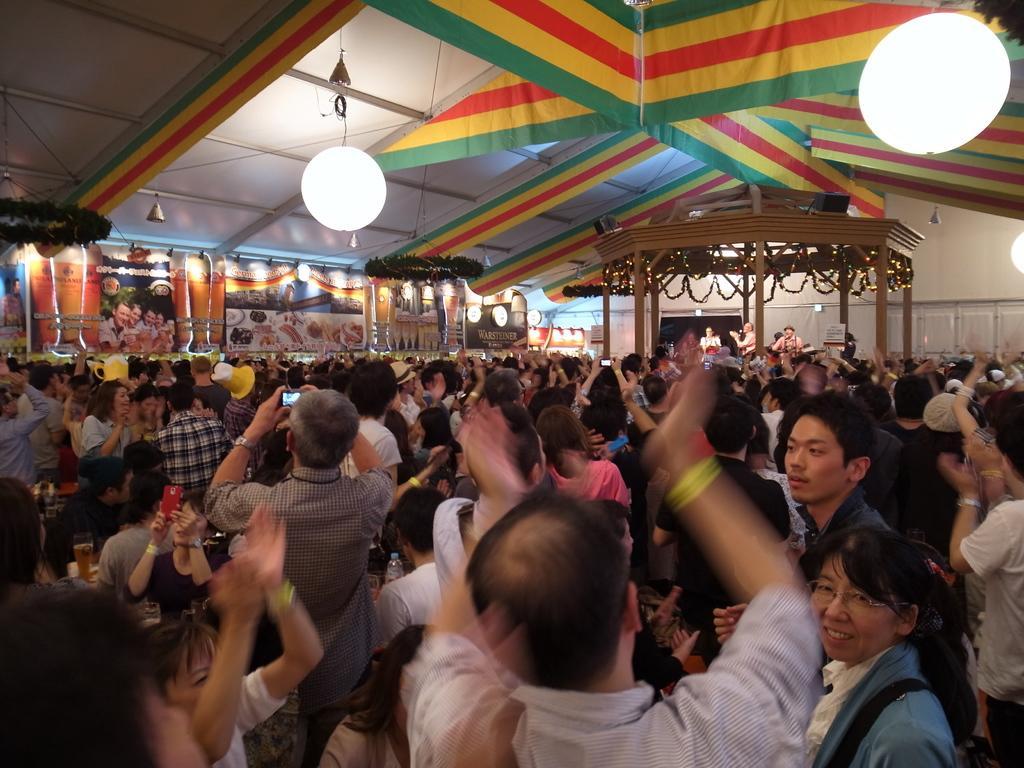Could you give a brief overview of what you see in this image? in this image I can see the group of people. These people are wearing the different color dresses and I can see few people are holding the mobiles and few are wearing the hats. In the back I can see some banners are attached to the wall. In the top I can see the colorful clothes are decorated. 